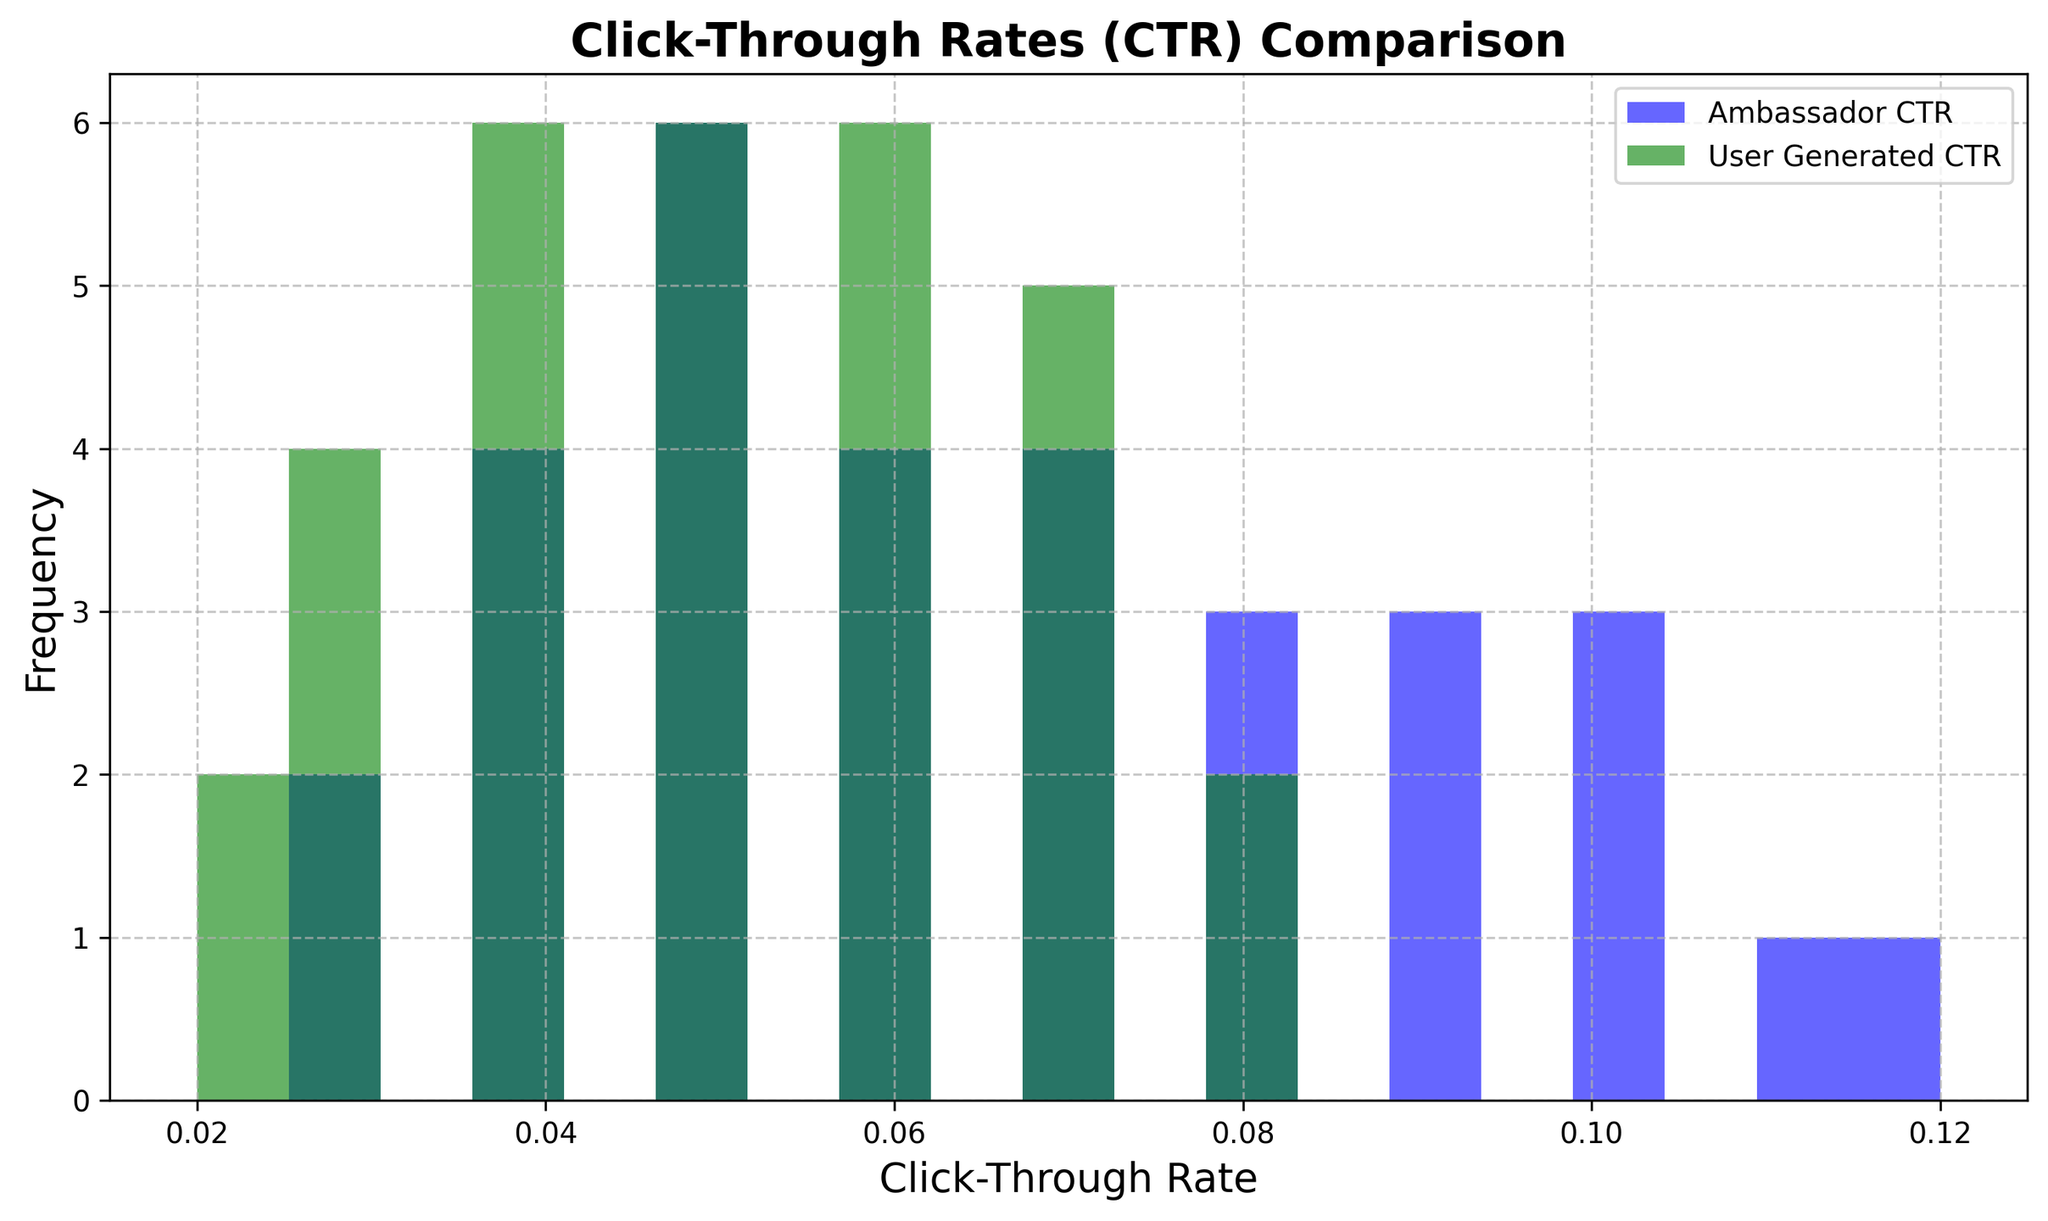What's the average Click-Through Rate (CTR) for posts created by ambassadors? To find the average, sum all CTR values for ambassadors and divide by the total number of values. The sum is 2.09, and there are 31 data points, so the average is 2.09 / 31.
Answer: 0.0674 Which CTR range has the highest frequency for ambassador posts? Observe the highest bar in the blue histogram and identify its position on the x-axis. The highest frequency occurs in the 0.05-0.07 range.
Answer: 0.05-0.07 How does the CTR distribution of user-generated content compare to that of ambassador posts? Compare the green and blue histograms. The green histogram (user-generated content) is overall lower and skewed to the left compared to the blue histogram (ambassador CTR), which means ambassador posts generally have a higher CTR.
Answer: User-generated content has lower CTR and is skewed left compared to ambassador posts Which group has a higher maximum CTR, ambassadors or user-generated content? Identify the furthest right bar in each histogram. The maximum CTR for ambassadors is in the range 0.11-0.12, whereas for user-generated content, it is in the range 0.07-0.08.
Answer: Ambassadors What percentage of user-generated content posts have a CTR below 0.06? Count bars in the green histogram up to 0.06. There are 7 bars (bins: 0.02, 0.025, 0.03, 0.035, 0.04, 0.045, 0.05), out of a total of 10 bars. The percentage is (7/10) * 100%.
Answer: 70% What is the spread of CTR values for ambassador posts? The spread (range) is found by subtracting the smallest value from the largest. The minimum is 0.03, and the maximum is 0.12.
Answer: 0.09 In which CTR range do ambassador posts and user-generated content posts both have the same frequency? Identify any bins with equal bar heights for both histograms. The range 0.04-0.05 has an equal frequency.
Answer: 0.04-0.05 What CTR range has the lowest frequency for user-generated content posts? Find the smallest bar in the green histogram. The lowest frequency occurs in the 0.07-0.08 range.
Answer: 0.07-0.08 Which group shows more variability in CTR, ambassadors or user-generated content? Greater variability is indicated by a wider spread of the histogram bars. The ambassador histogram has a wider spread from 0.03 to 0.12 compared to the user-generated content spread from 0.02 to 0.08.
Answer: Ambassadors 